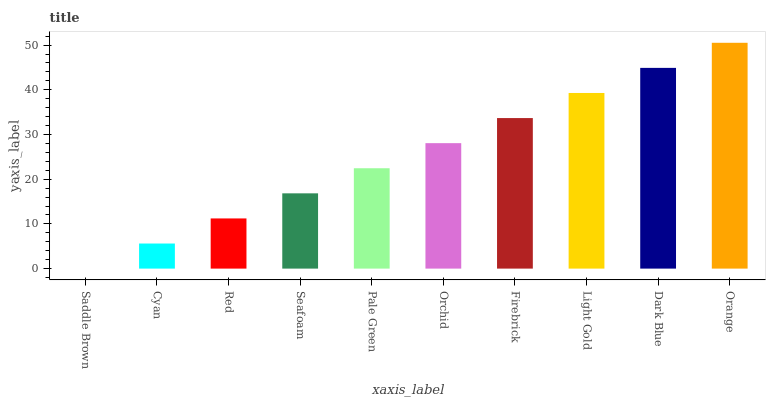Is Cyan the minimum?
Answer yes or no. No. Is Cyan the maximum?
Answer yes or no. No. Is Cyan greater than Saddle Brown?
Answer yes or no. Yes. Is Saddle Brown less than Cyan?
Answer yes or no. Yes. Is Saddle Brown greater than Cyan?
Answer yes or no. No. Is Cyan less than Saddle Brown?
Answer yes or no. No. Is Orchid the high median?
Answer yes or no. Yes. Is Pale Green the low median?
Answer yes or no. Yes. Is Orange the high median?
Answer yes or no. No. Is Orange the low median?
Answer yes or no. No. 